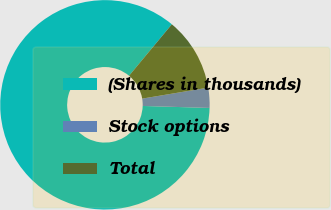Convert chart. <chart><loc_0><loc_0><loc_500><loc_500><pie_chart><fcel>(Shares in thousands)<fcel>Stock options<fcel>Total<nl><fcel>85.56%<fcel>3.1%<fcel>11.34%<nl></chart> 